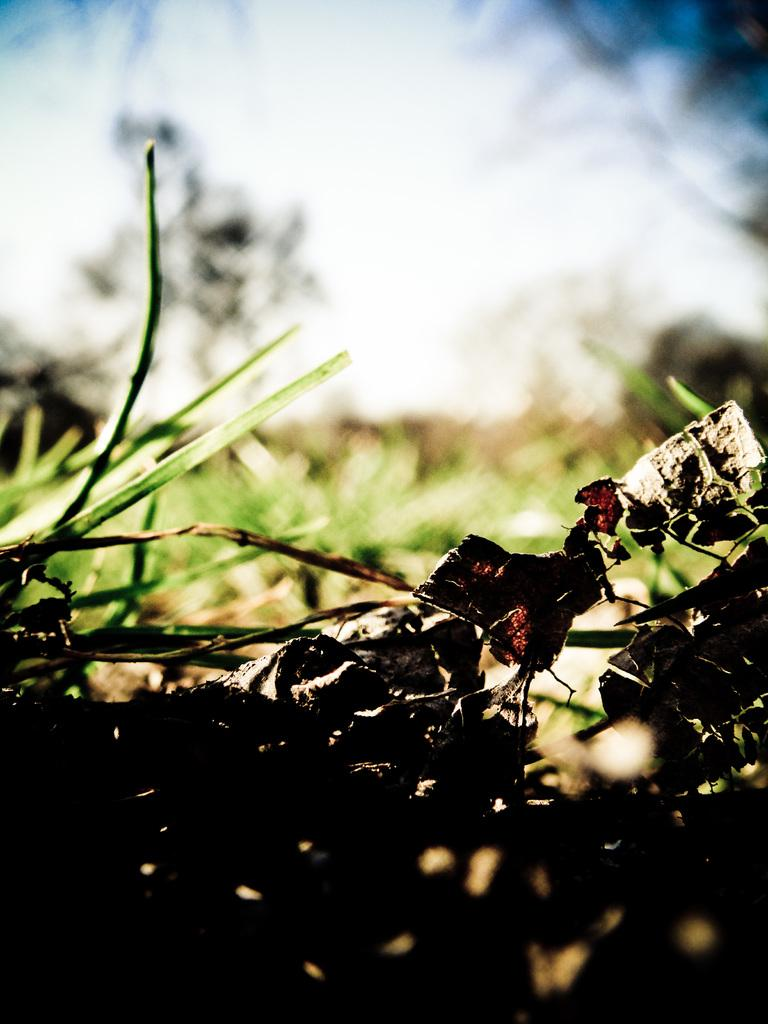What type of living organisms can be seen in the image? Plants and a tree are visible in the image. What is visible in the background of the image? The sky is visible in the image. How would you describe the quality of the image? The image is slightly blurred. What type of error can be seen in the image? There is no error present in the image; it is a photograph of plants, a tree, and the sky. What activity is being performed by the power in the image? There is no power or activity related to power present in the image. 